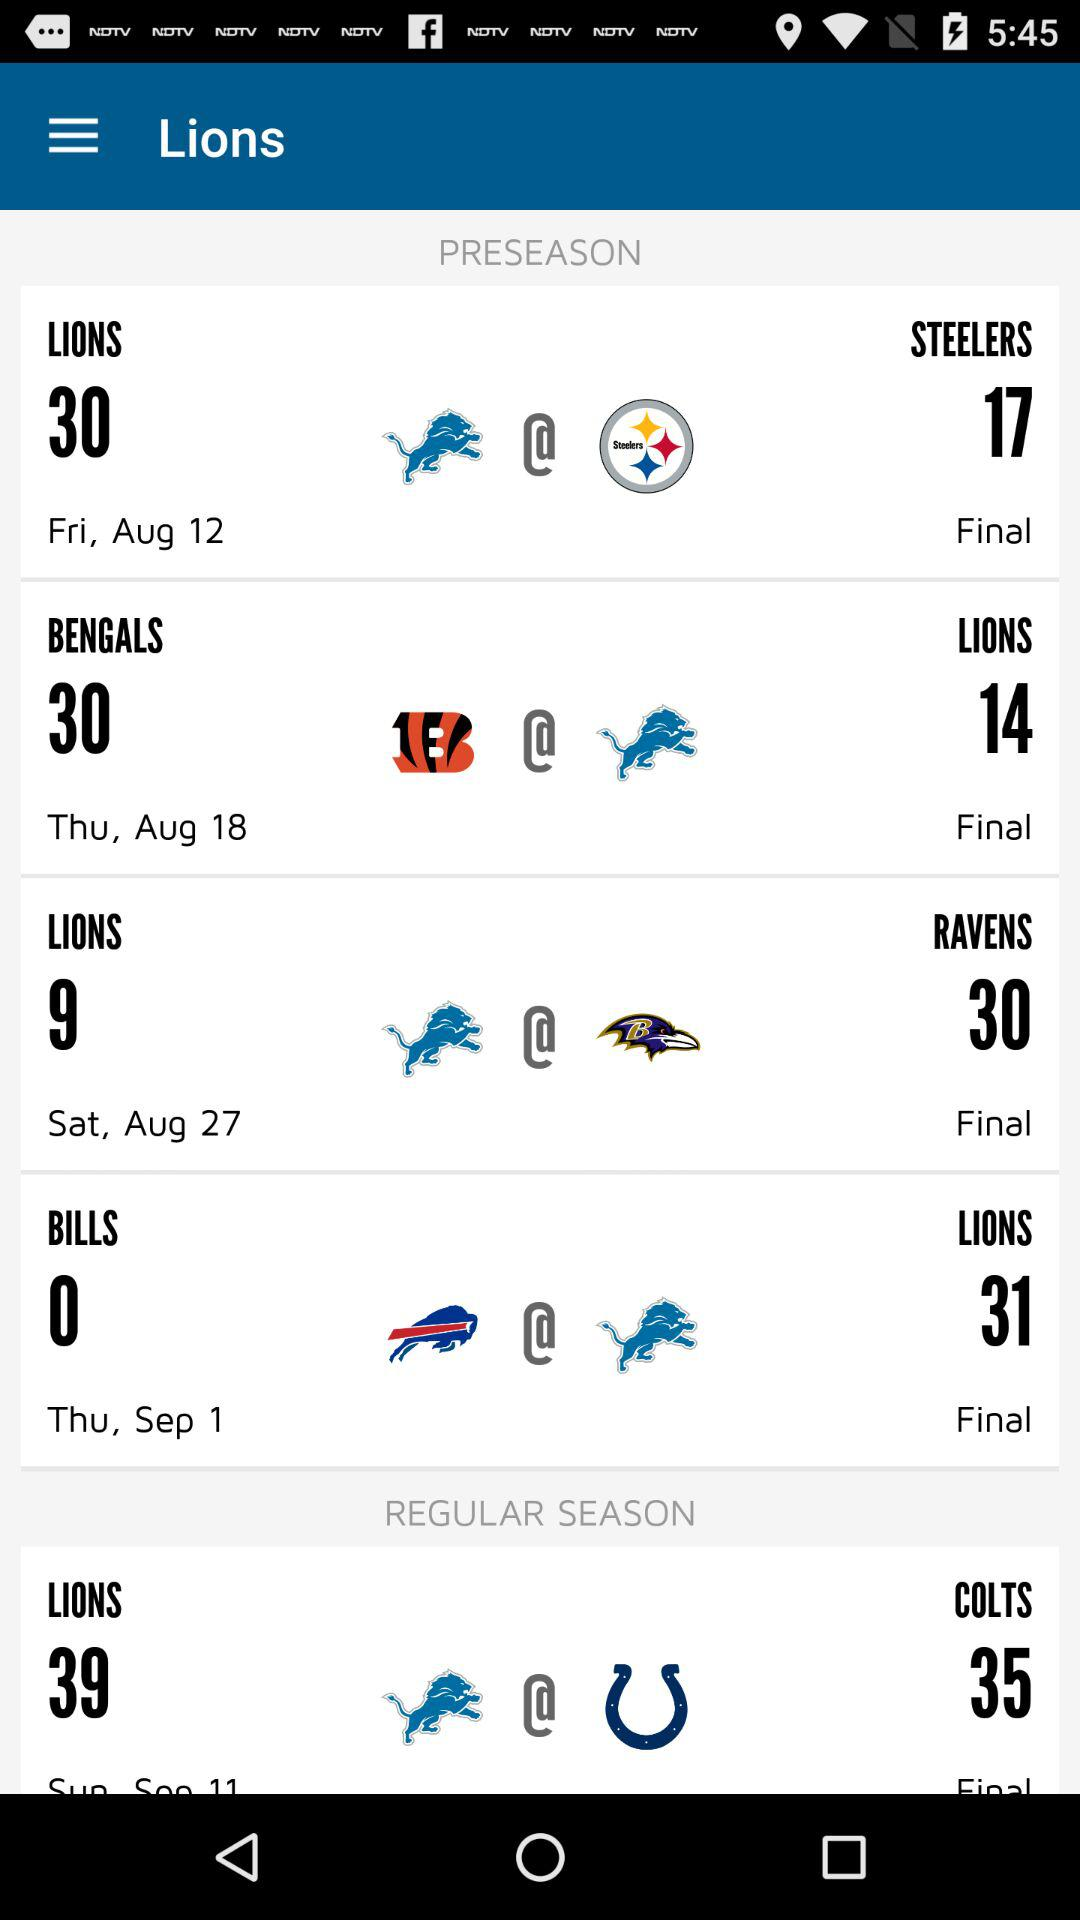When did the "Lions" play the "Colts"?
When the provided information is insufficient, respond with <no answer>. <no answer> 